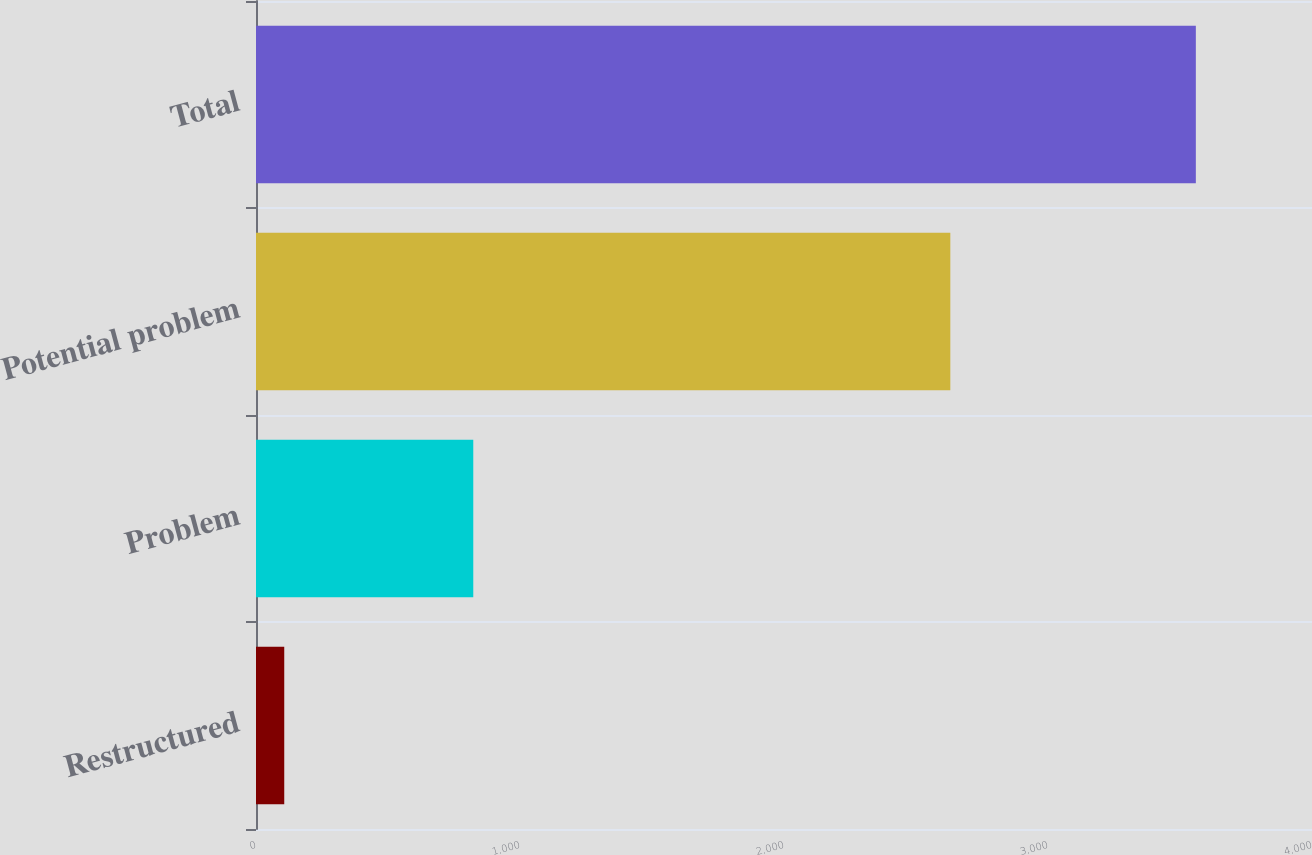Convert chart to OTSL. <chart><loc_0><loc_0><loc_500><loc_500><bar_chart><fcel>Restructured<fcel>Problem<fcel>Potential problem<fcel>Total<nl><fcel>107<fcel>823<fcel>2630<fcel>3560<nl></chart> 